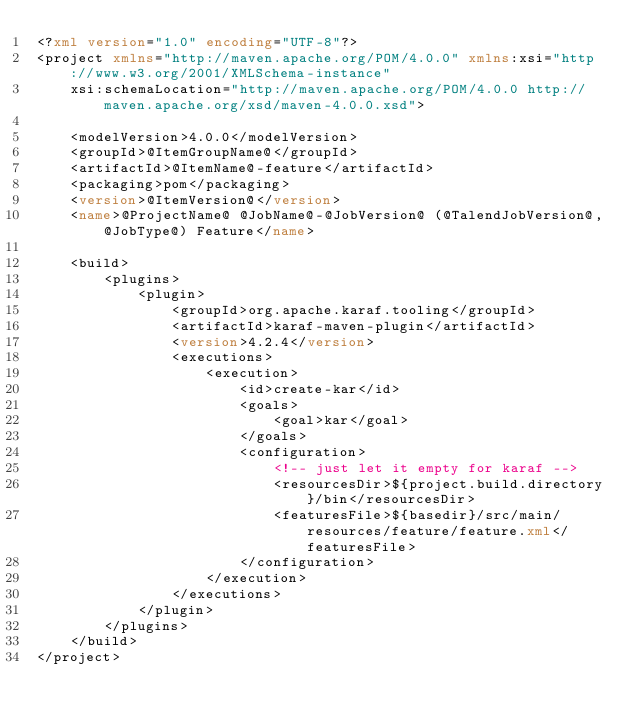<code> <loc_0><loc_0><loc_500><loc_500><_XML_><?xml version="1.0" encoding="UTF-8"?>
<project xmlns="http://maven.apache.org/POM/4.0.0" xmlns:xsi="http://www.w3.org/2001/XMLSchema-instance"
    xsi:schemaLocation="http://maven.apache.org/POM/4.0.0 http://maven.apache.org/xsd/maven-4.0.0.xsd">

    <modelVersion>4.0.0</modelVersion>
    <groupId>@ItemGroupName@</groupId>
    <artifactId>@ItemName@-feature</artifactId>
    <packaging>pom</packaging>
    <version>@ItemVersion@</version>
    <name>@ProjectName@ @JobName@-@JobVersion@ (@TalendJobVersion@,@JobType@) Feature</name>
    
    <build>
        <plugins>
            <plugin>
                <groupId>org.apache.karaf.tooling</groupId>
                <artifactId>karaf-maven-plugin</artifactId>
                <version>4.2.4</version>
                <executions>
                    <execution>
                        <id>create-kar</id>
                        <goals>
                            <goal>kar</goal>
                        </goals>
                        <configuration>
                            <!-- just let it empty for karaf -->
                            <resourcesDir>${project.build.directory}/bin</resourcesDir>
                            <featuresFile>${basedir}/src/main/resources/feature/feature.xml</featuresFile>
                        </configuration>
                    </execution>
                </executions>
            </plugin>
        </plugins>
    </build>
</project></code> 